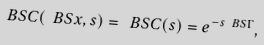<formula> <loc_0><loc_0><loc_500><loc_500>\ B S C ( \ B S x , s ) = \ B S C ( s ) = e ^ { - s \ B S \Gamma } ,</formula> 